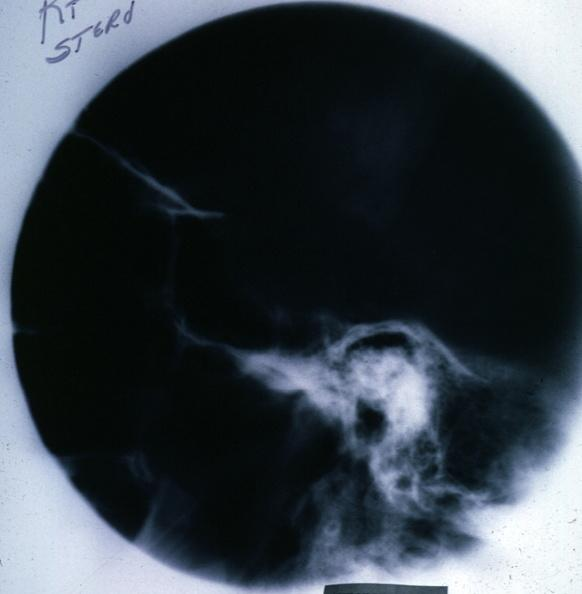s endocrine present?
Answer the question using a single word or phrase. Yes 